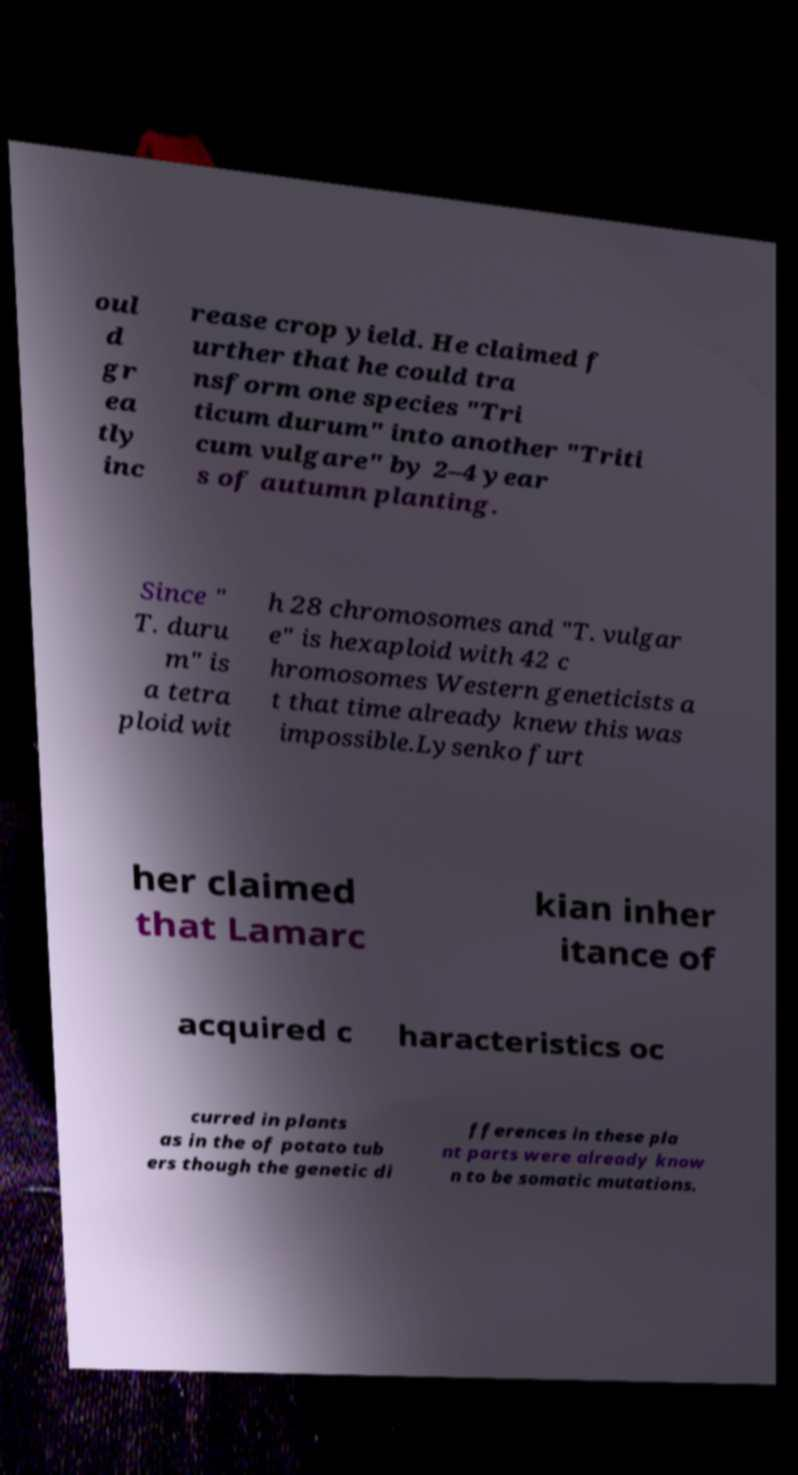What messages or text are displayed in this image? I need them in a readable, typed format. oul d gr ea tly inc rease crop yield. He claimed f urther that he could tra nsform one species "Tri ticum durum" into another "Triti cum vulgare" by 2–4 year s of autumn planting. Since " T. duru m" is a tetra ploid wit h 28 chromosomes and "T. vulgar e" is hexaploid with 42 c hromosomes Western geneticists a t that time already knew this was impossible.Lysenko furt her claimed that Lamarc kian inher itance of acquired c haracteristics oc curred in plants as in the of potato tub ers though the genetic di fferences in these pla nt parts were already know n to be somatic mutations. 